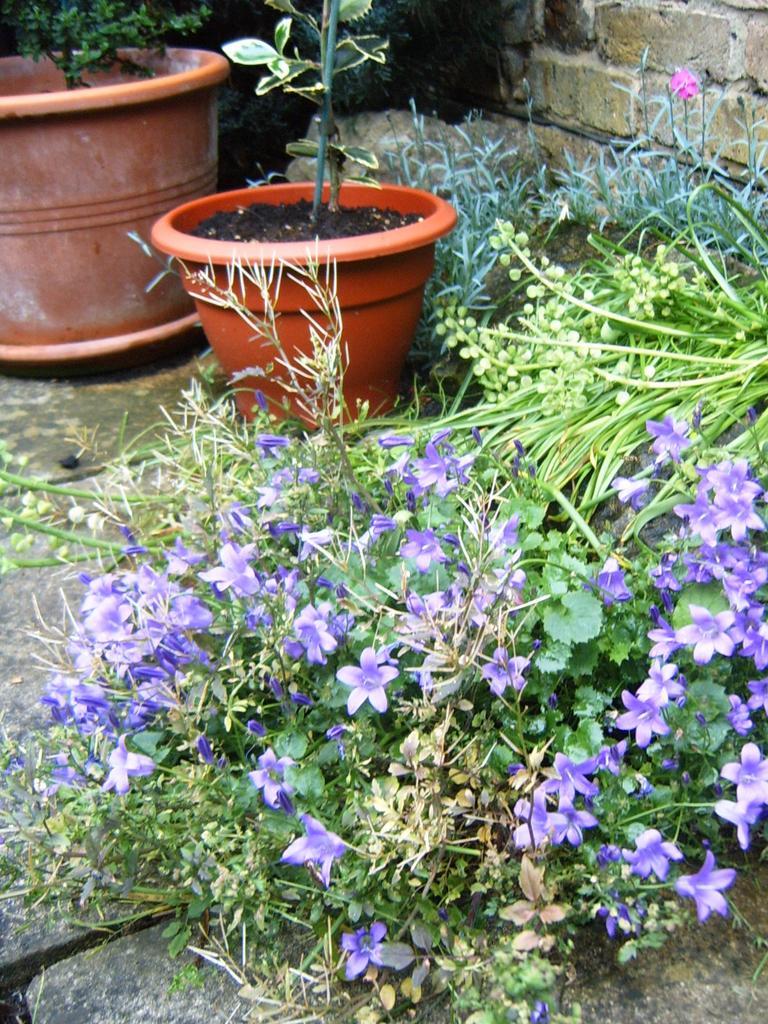Can you describe this image briefly? In this image we can see the flower pots, plants, grass and also the flowers. We can also see the brick wall and also the land. 